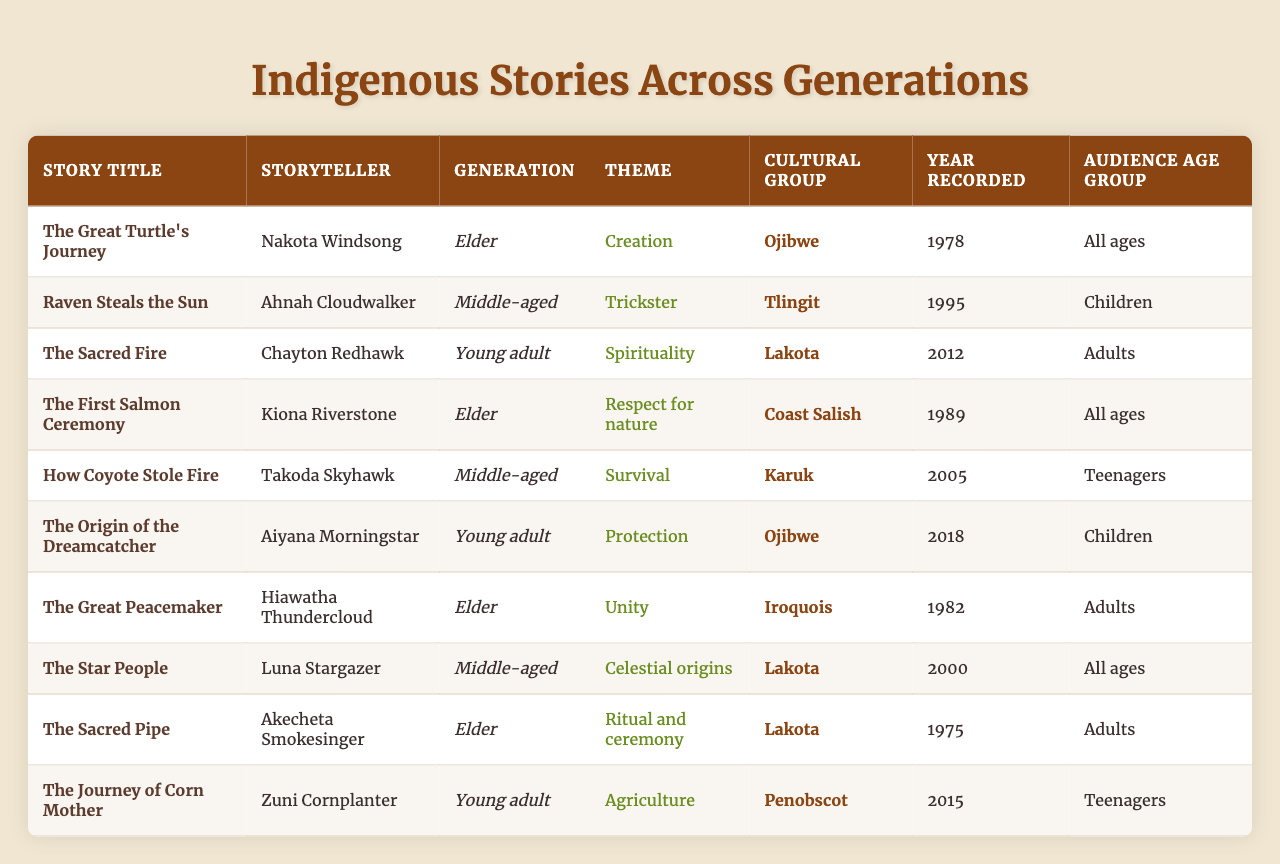What are the themes represented in the stories? The themes can be retrieved from the "Theme" column of the table. They include Creation, Trickster, Spirituality, Respect for nature, Survival, Protection, Unity, Celestial origins, Ritual and ceremony, and Agriculture.
Answer: Creation, Trickster, Spirituality, Respect for nature, Survival, Protection, Unity, Celestial origins, Ritual and ceremony, Agriculture How many stories were recorded in the Elder generation? By counting the rows where the "Generation" column is marked as "Elder," we find 4 stories (The Great Turtle's Journey, The First Salmon Ceremony, The Great Peacemaker, The Sacred Pipe).
Answer: 4 What is the earliest year recorded in this table? The "Year Recorded" column shows the earliest entry is for The Sacred Pipe in 1975. By checking the years, 1975 is the minimum year.
Answer: 1975 Which cultural group has the most recent recorded story? The most recent story is The Origin of the Dreamcatcher from the Ojibwe cultural group recorded in 2018. By checking the years, 2018 is the most recent.
Answer: Ojibwe Is there a story from the Tlingit cultural group aimed at adults? By checking the age groups associated with the Tlingit stories, Raven Steals the Sun is targeted toward children, making there are no stories aimed at adults from this group.
Answer: No How many stories feature themes related to the Trickster archetype? Looking at the "Theme" column, only one story (Raven Steals the Sun) is identified with the Trickster theme. Therefore, the count is 1.
Answer: 1 Which generation includes stories with the theme of spirituality? The "Theme" column shows that "Spirituality" appears in the story "The Sacred Fire," which belongs to the Young adult generation.
Answer: Young adult What percentage of the stories are targeted towards children? There are 10 stories in total, and 3 of them (Raven Steals the Sun, The Origin of the Dreamcatcher, and The First Salmon Ceremony) are aimed at children. The percentage is (3/10) * 100 = 30%.
Answer: 30% How many themes are related to nature? The themes related to nature are "Respect for nature," "Creation," and "Agriculture". Therefore, there are 3 themes identified.
Answer: 3 What story has the theme of unity and who is the storyteller? The story "The Great Peacemaker" has the theme of Unity, and it was told by Hiawatha Thundercloud.
Answer: The Great Peacemaker, Hiawatha Thundercloud 